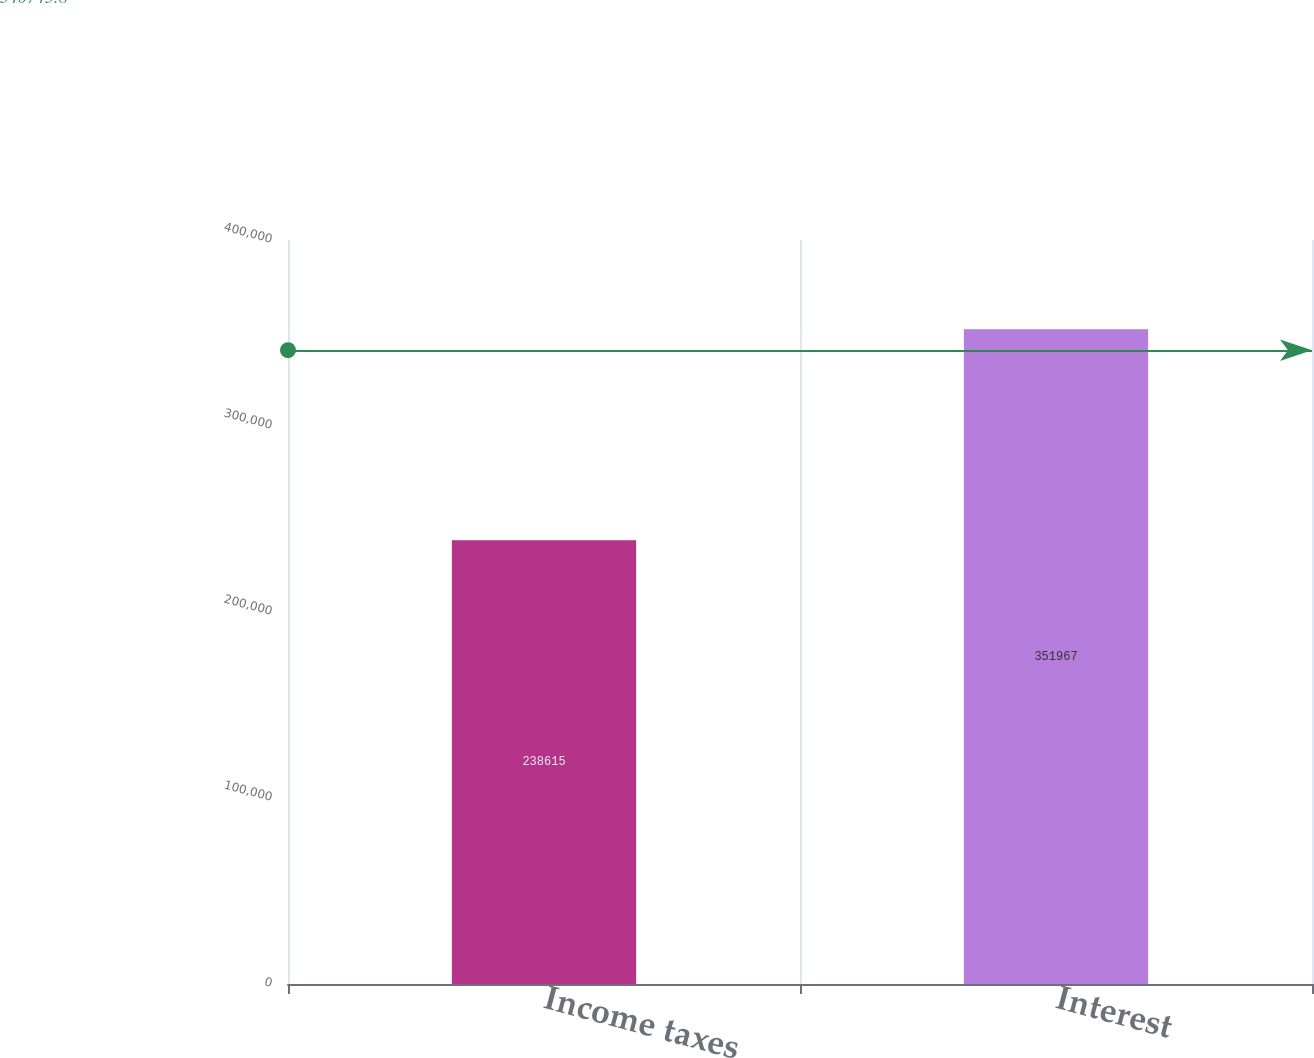Convert chart. <chart><loc_0><loc_0><loc_500><loc_500><bar_chart><fcel>Income taxes<fcel>Interest<nl><fcel>238615<fcel>351967<nl></chart> 